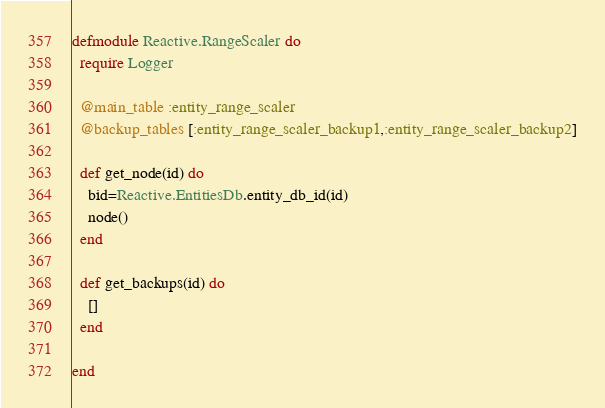Convert code to text. <code><loc_0><loc_0><loc_500><loc_500><_Elixir_>defmodule Reactive.RangeScaler do
  require Logger

  @main_table :entity_range_scaler
  @backup_tables [:entity_range_scaler_backup1,:entity_range_scaler_backup2]

  def get_node(id) do
    bid=Reactive.EntitiesDb.entity_db_id(id)
    node()
  end

  def get_backups(id) do
    []
  end

end</code> 